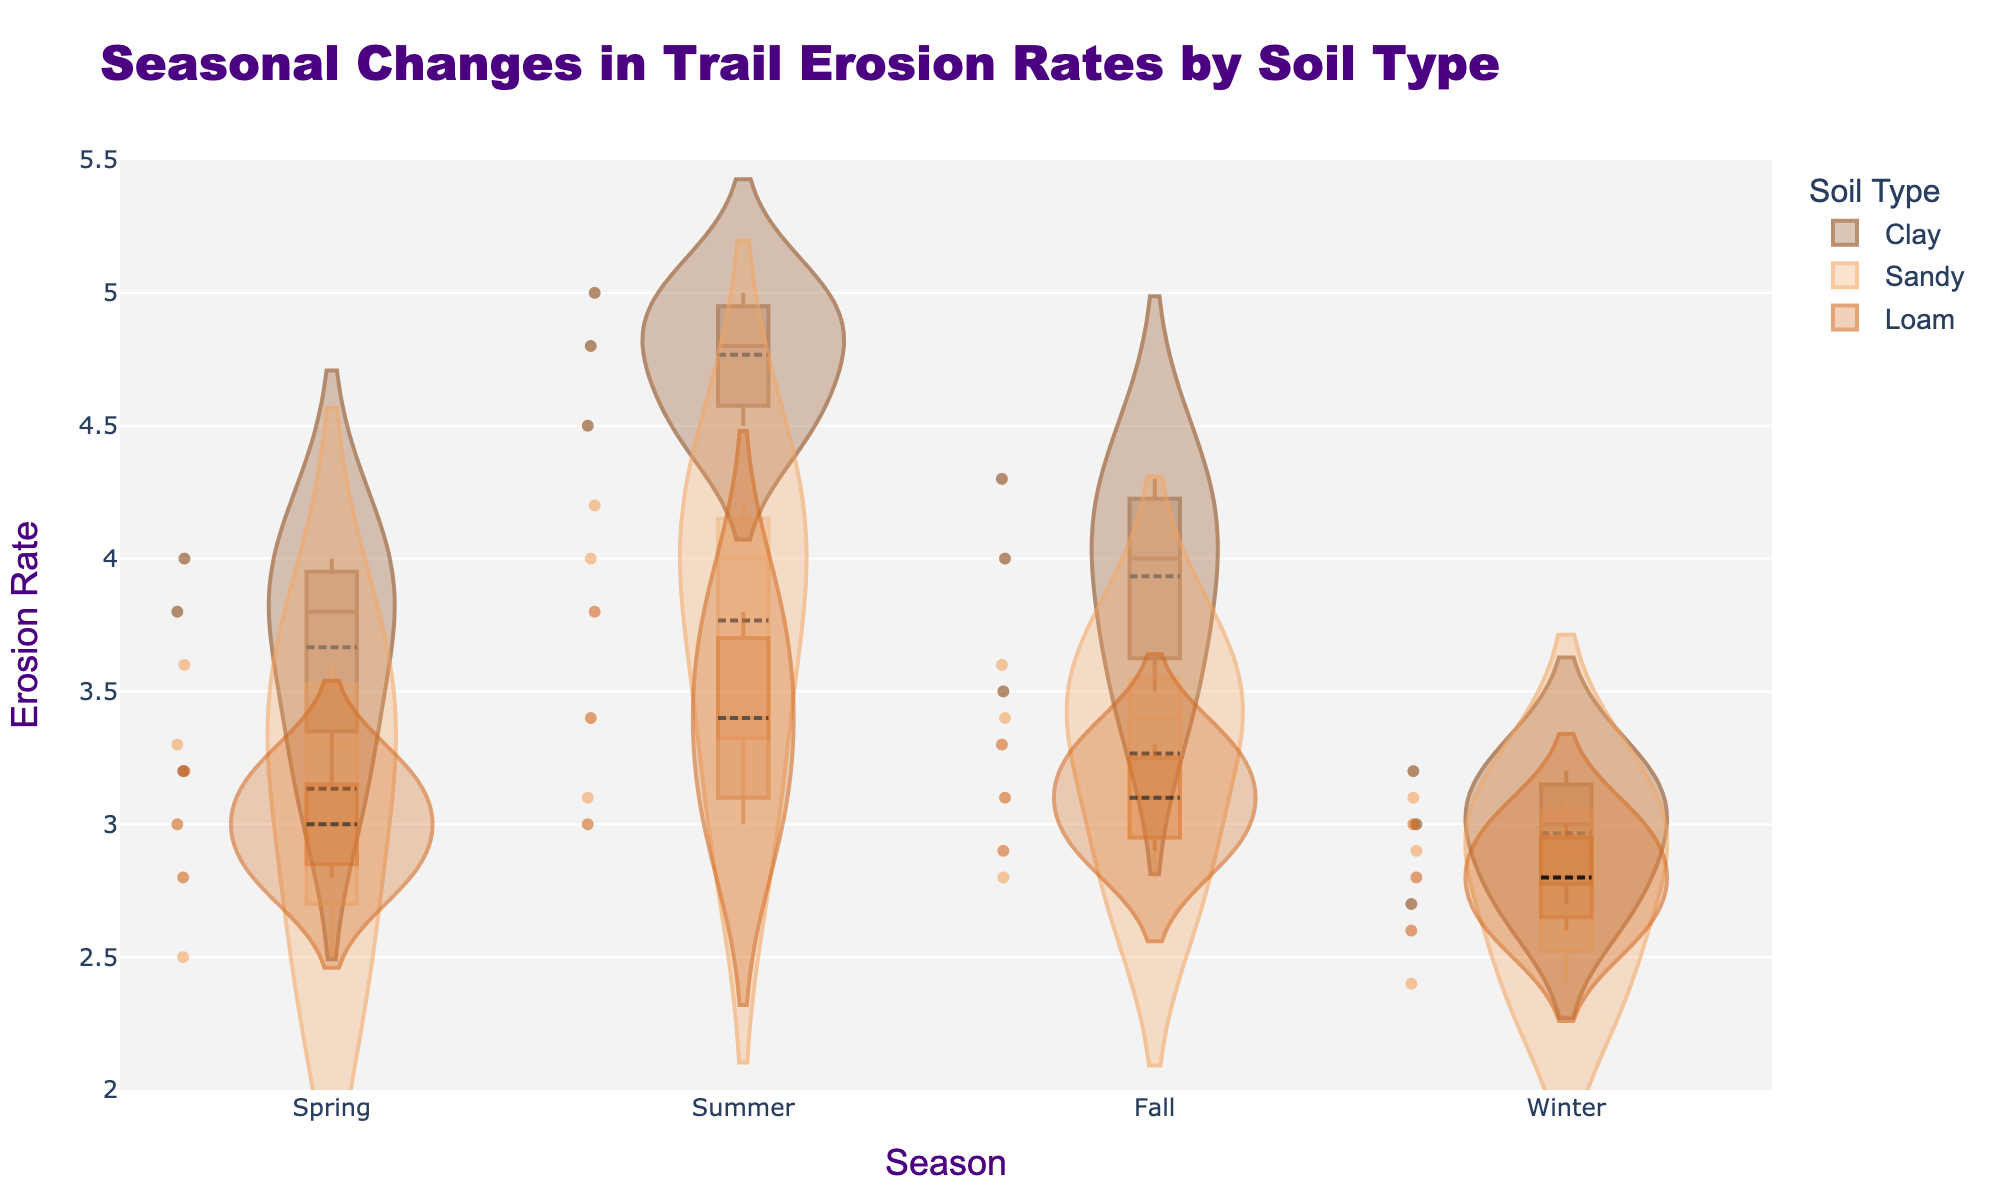What is the title of the figure? The title is located at the top center of the figure and reads "Seasonal Changes in Trail Erosion Rates by Soil Type."
Answer: Seasonal Changes in Trail Erosion Rates by Soil Type Which season shows the highest median erosion rate for clay soil? Look for the box plot embedded within the clay soil violin plot for each season. The tallest median line will indicate the highest median erosion rate. The summer season shows the highest position for the median line.
Answer: Summer What is the range of the y-axis? The y-axis shows erosion rates, and the range is indicated by the values at the bottom and top of the axis. The y-axis ranges from 2 to 5.5.
Answer: 2 to 5.5 Are there any outliers visible for loam soil in the winter season? Check the winter section within the loam soil violin plot specifically for individual points that lie outside the central concentration of data. There are no points significantly distant from the central mass.
Answer: No Which soil type has the most variation in erosion rates during the fall season? Evaluate the spread or width of each soil type's violin plot for the fall season. The clay soil shows the widest shape, indicating the most variation.
Answer: Clay What's the approximate mean erosion rate for sandy soil in the spring season? Locate the mean line within the spring section for sandy soil in the violin plot. It is positioned around 3.1.
Answer: 3.1 How do the erosion rates for clay soil in the winter season compare to those in the summer season? Compare the winter and summer sections of the clay soil violin plot. The median line and overall distribution in summer are higher than in winter.
Answer: Higher in summer Which season has the least variation in erosion rates for loam soil? Assess the spread of each season's violin plot for loam soil. The winter season shows the narrowest violin plot, indicating the least variation.
Answer: Winter Do sandy soils exhibit higher erosion rates in the summer than in the spring? Compare the distribution and median lines of sandy soils in the summer and spring sections. The summer distribution and median lines are higher, indicating higher rates in summer.
Answer: Yes Which soils have overlapping erosion rate distributions in the spring season? Observe the spring section of the violin plots. Loam and sandy soils' distributions overlap considerably in the spring season.
Answer: Loam and Sandy 